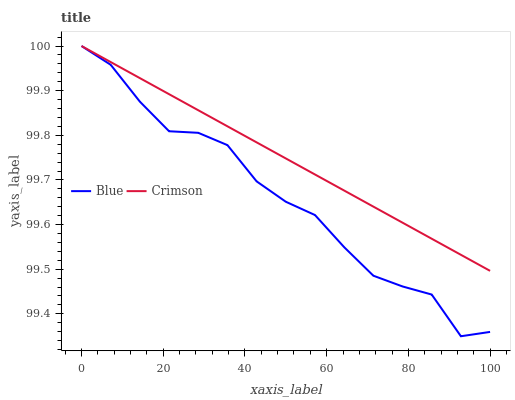Does Blue have the minimum area under the curve?
Answer yes or no. Yes. Does Crimson have the maximum area under the curve?
Answer yes or no. Yes. Does Crimson have the minimum area under the curve?
Answer yes or no. No. Is Crimson the smoothest?
Answer yes or no. Yes. Is Blue the roughest?
Answer yes or no. Yes. Is Crimson the roughest?
Answer yes or no. No. Does Crimson have the lowest value?
Answer yes or no. No. Does Crimson have the highest value?
Answer yes or no. Yes. Does Blue intersect Crimson?
Answer yes or no. Yes. Is Blue less than Crimson?
Answer yes or no. No. Is Blue greater than Crimson?
Answer yes or no. No. 